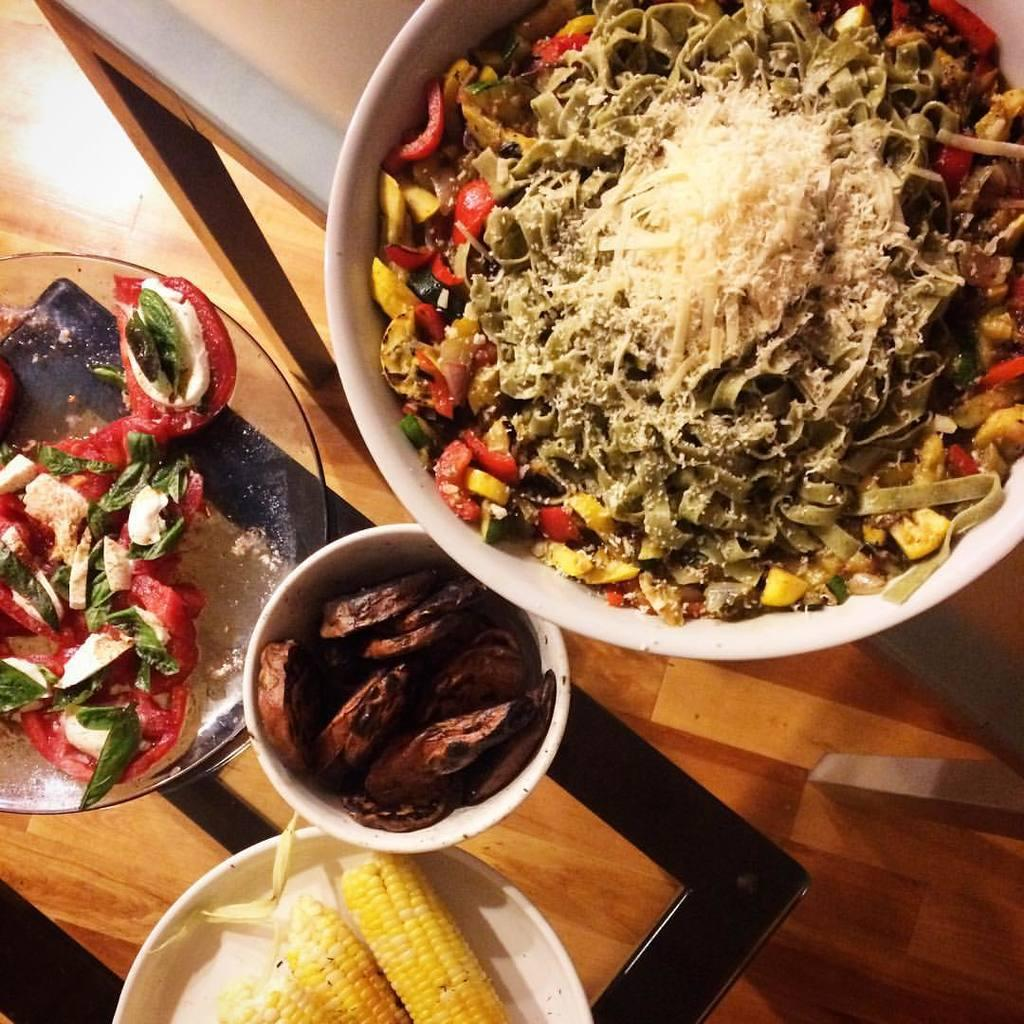What is in the bowl that is visible in the image? There is a bowl with food in the image. What color is the bowl? The bowl is white in color. Where is the bowl placed? The bowl is placed on a glass table. What is on the plate next to the bowl? There is a plate with three corn in the image. What color is the plate? The plate is white in color. Is there a crown on the table in the image? No, there is no crown present in the image. How does the bowl provide support for the corn? The bowl and the corn are separate items in the image, so the bowl does not provide support for the corn. 